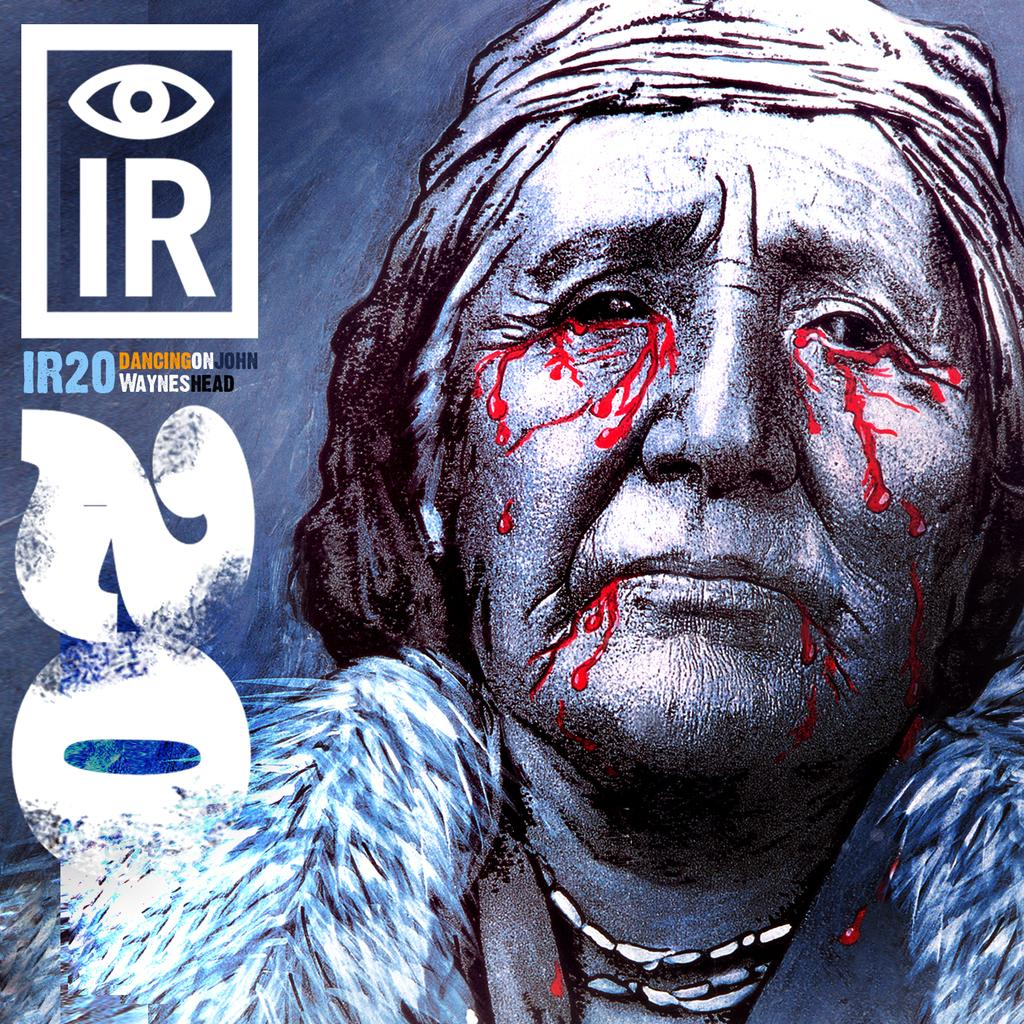What is the main subject of the poster in the image? The poster contains an image of a woman. Where is the text located on the poster? The text is on the left side of the poster. Can you describe the appearance of the poster? The image appears to be edited. What type of riddle can be seen on the poster? There is no riddle present on the poster; it contains an image of a woman and text on the left side. Can you describe the knot that the woman is holding in the image? There is no knot present in the image; the woman is not holding any object. 